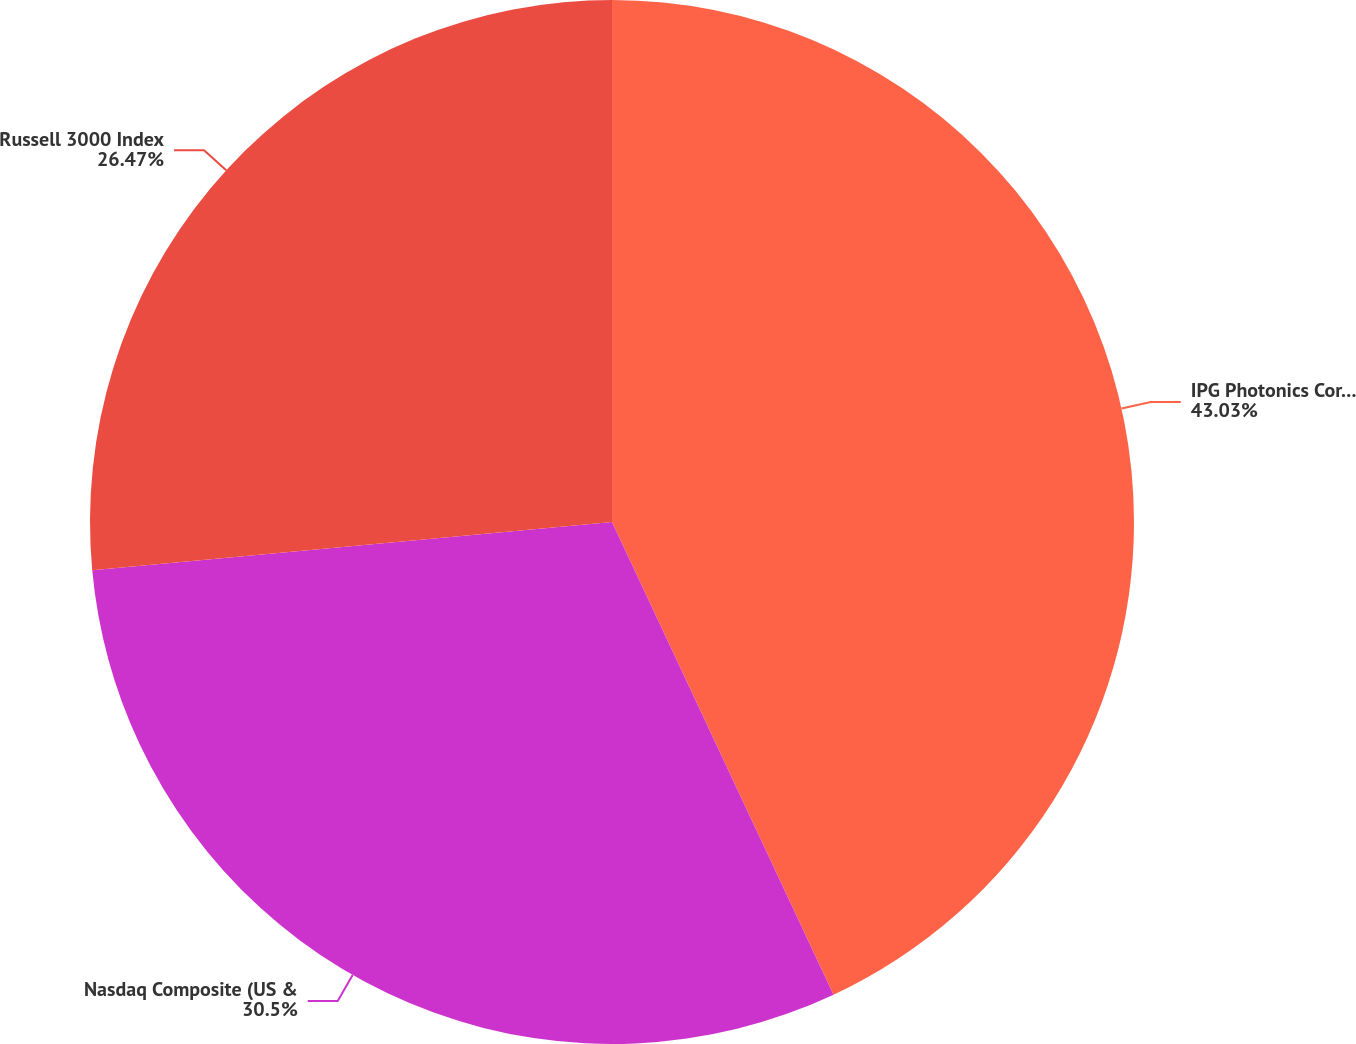Convert chart. <chart><loc_0><loc_0><loc_500><loc_500><pie_chart><fcel>IPG Photonics Corporation<fcel>Nasdaq Composite (US &<fcel>Russell 3000 Index<nl><fcel>43.02%<fcel>30.5%<fcel>26.47%<nl></chart> 